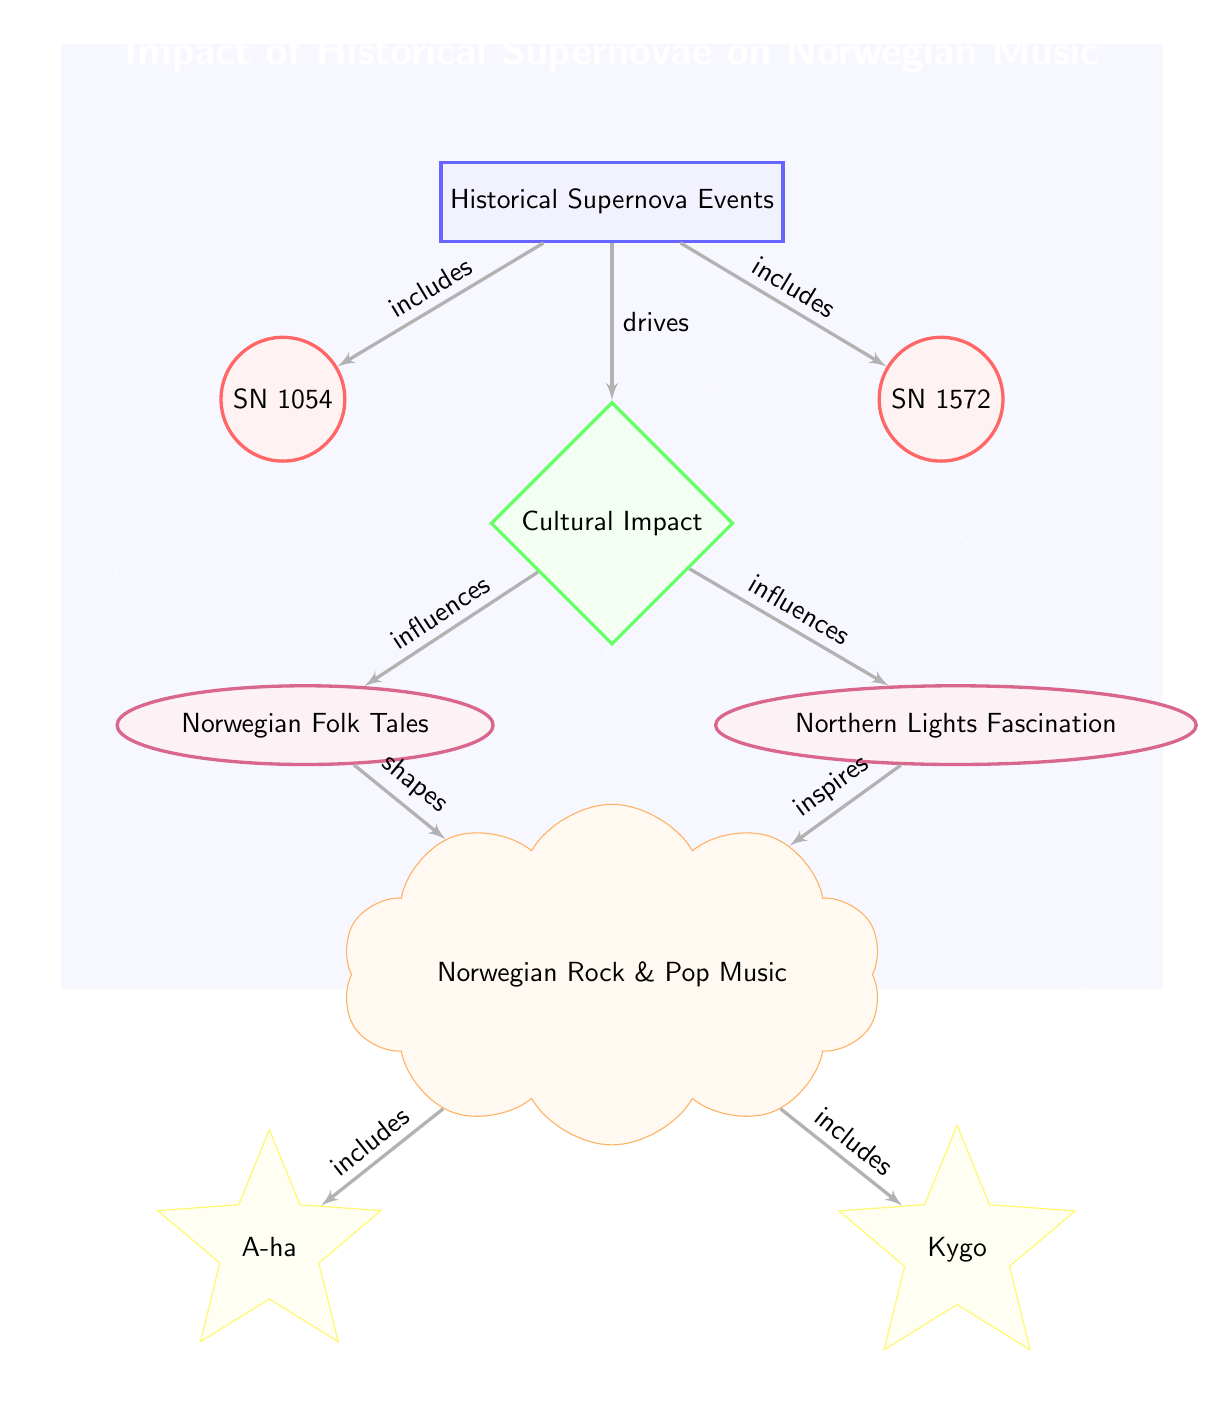What are the two historical supernovae events mentioned? The diagram explicitly labels two historical supernovae events: SN 1054 and SN 1572, represented by circles.
Answer: SN 1054, SN 1572 How many nodes are directly related to cultural impact? The diagram shows one main cultural impact node with two directly connected influence nodes (Norwegian Folk Tales and Northern Lights Fascination), resulting in three nodes related to cultural impact.
Answer: 3 What does the cultural impact drive? The diagram indicates that the cultural impact drives the development of Norwegian Rock & Pop Music, shown by the direct edge connecting the two nodes.
Answer: Norwegian Rock & Pop Music Which two artists are illustrated in the context of Norwegian Rock and Pop Music? The diagram lists two artists as part of Norwegian Rock & Pop Music: A-ha and Kygo, represented by star-shaped nodes below the culture node.
Answer: A-ha, Kygo What influences Norwegian Rock and Pop Music? The diagram details that both Norwegian Folk Tales and Northern Lights Fascination influence Norwegian Rock & Pop Music, indicated by the edges leading from these influence nodes.
Answer: Norwegian Folk Tales, Northern Lights Fascination How many edges are drawn from the Cultural Impact node? The Cultural Impact node is connected to three edges leading towards Norwegian Folk Tales, Northern Lights Fascination, and Norwegian Rock & Pop Music, thus having three outgoing edges.
Answer: 3 What is the relationship between Norwegian Folk Tales and Rock & Pop Music? The diagram shows that Norwegian Folk Tales shape Norwegian Rock & Pop Music, indicated by the directed edge from the folk tales to the music node.
Answer: shapes What role do historical supernovae events play in this diagram? Historical supernovae events, represented at the top of the diagram, are the starting point contributing to cultural impact and, subsequently, Norwegian Rock and Pop Music.
Answer: drives cultural impact How are the Northern Lights represented in the diagram? The Northern Lights are represented as an influence node that affects Norwegian Rock & Pop Music, connected by an edge specifying its inspirational role.
Answer: inspires 